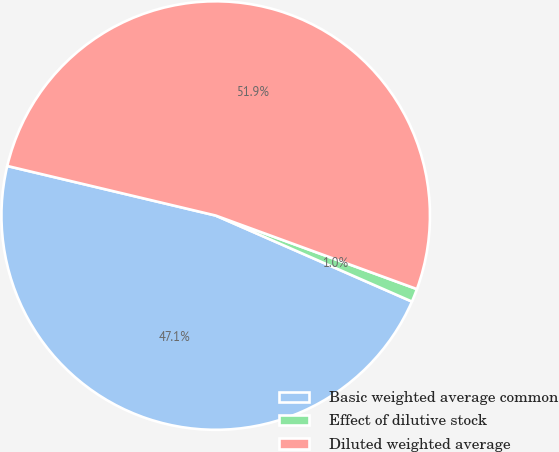Convert chart. <chart><loc_0><loc_0><loc_500><loc_500><pie_chart><fcel>Basic weighted average common<fcel>Effect of dilutive stock<fcel>Diluted weighted average<nl><fcel>47.14%<fcel>1.0%<fcel>51.86%<nl></chart> 